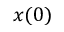<formula> <loc_0><loc_0><loc_500><loc_500>x ( 0 )</formula> 